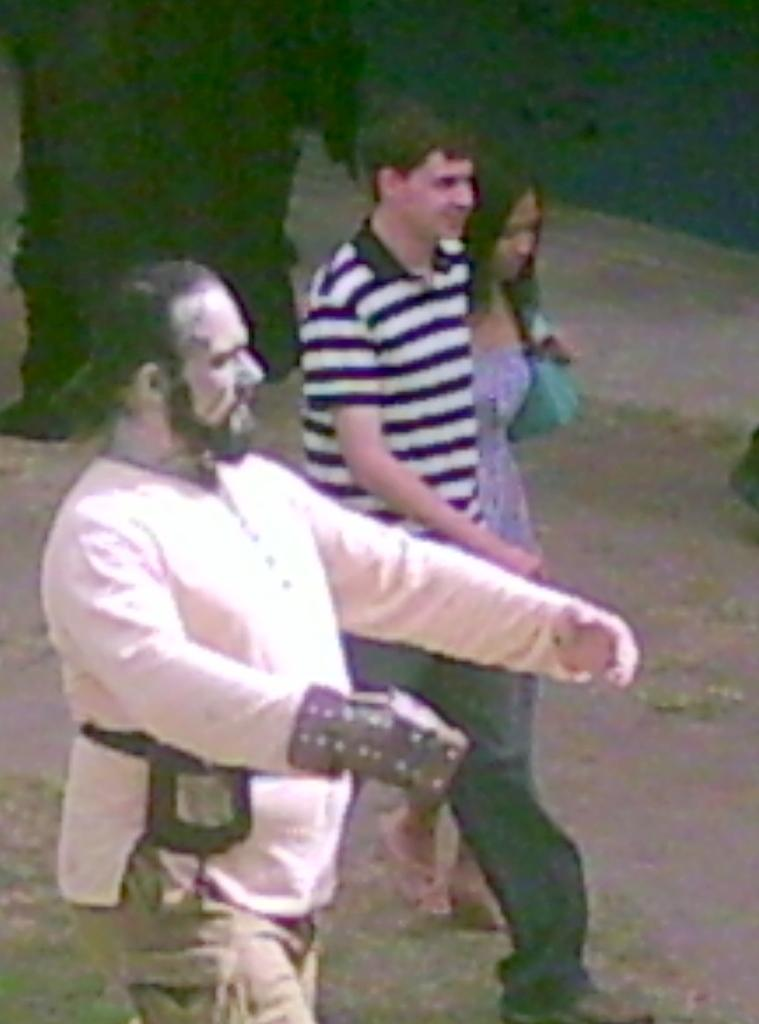What are the people in the image doing? The people in the image are walking. Can you describe the background of the image? The background of the image is dark. What type of operation is being performed on the worm in the image? There is no worm or operation present in the image; it features people walking with a dark background. 